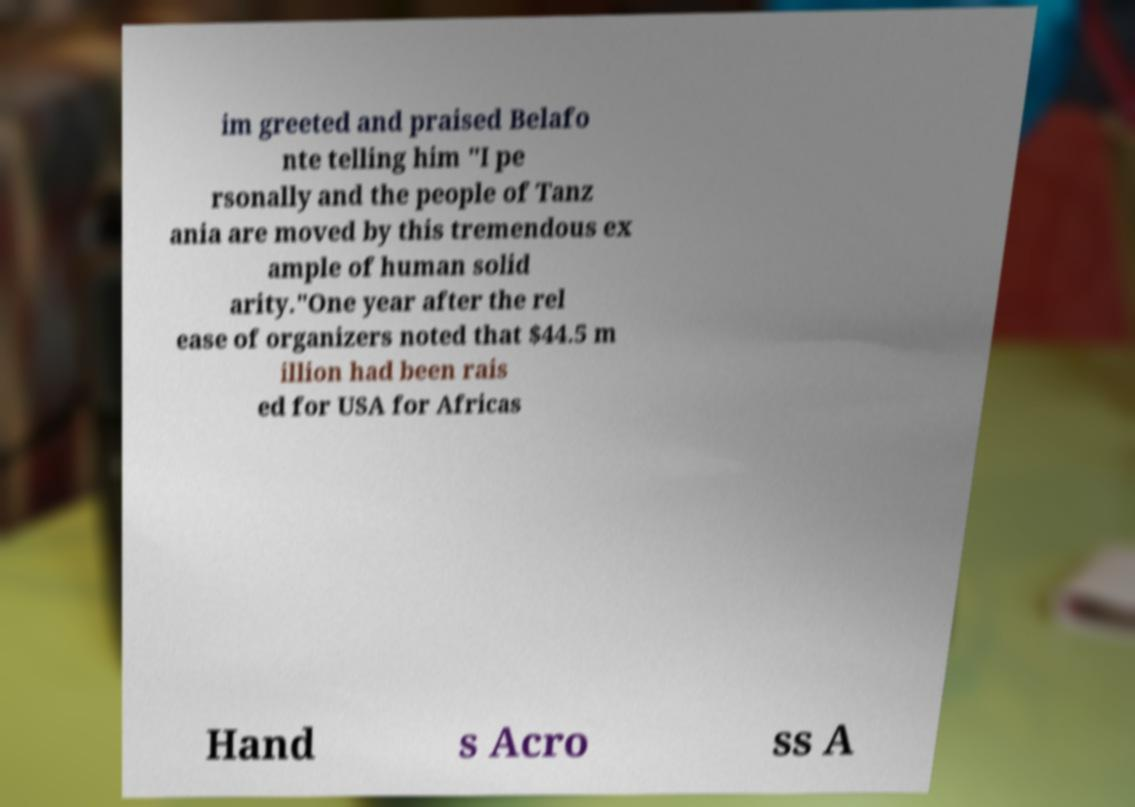Could you assist in decoding the text presented in this image and type it out clearly? im greeted and praised Belafo nte telling him "I pe rsonally and the people of Tanz ania are moved by this tremendous ex ample of human solid arity."One year after the rel ease of organizers noted that $44.5 m illion had been rais ed for USA for Africas Hand s Acro ss A 